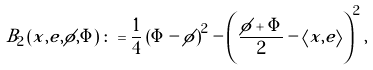Convert formula to latex. <formula><loc_0><loc_0><loc_500><loc_500>B _ { 2 } \left ( x , e , \phi , \Phi \right ) \colon = \frac { 1 } { 4 } \left ( \Phi - \phi \right ) ^ { 2 } - \left ( \frac { \phi + \Phi } { 2 } - \left \langle x , e \right \rangle \right ) ^ { 2 } ,</formula> 